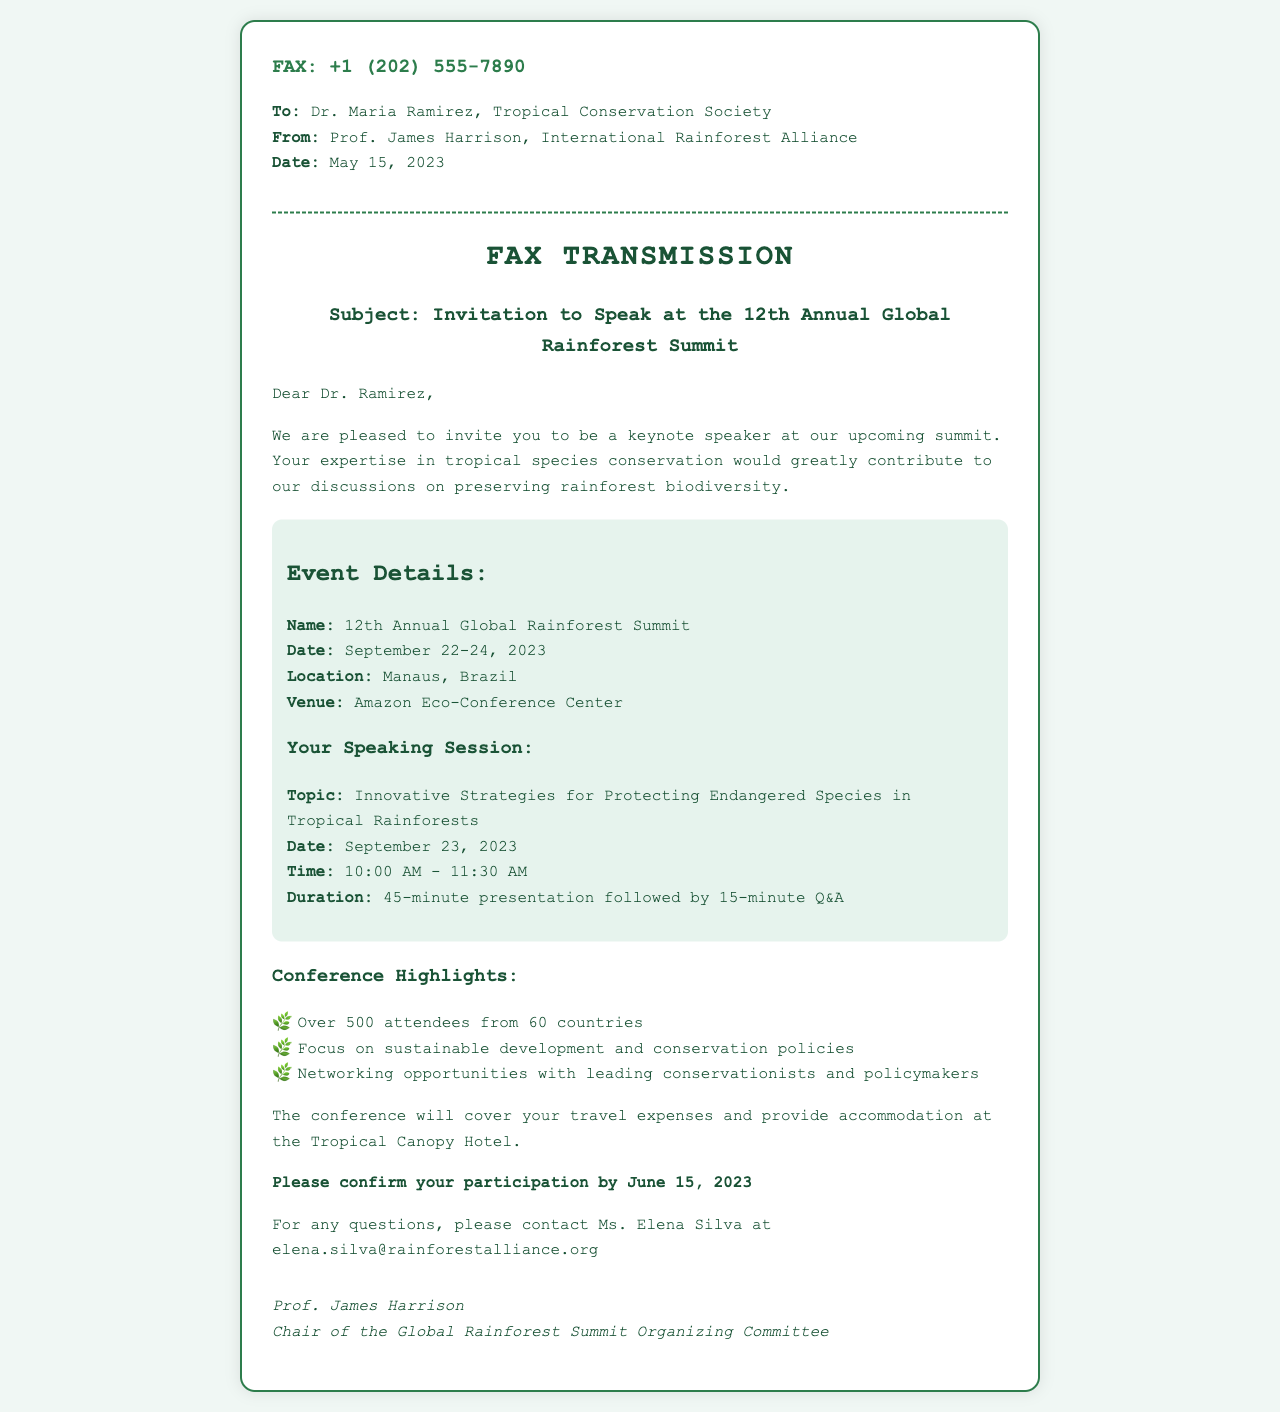What is the fax number? The fax number is provided at the top of the document.
Answer: +1 (202) 555-7890 Who is the recipient of the fax? The document specifies the recipient in the address section.
Answer: Dr. Maria Ramirez When is the conference scheduled to take place? The document states the date of the conference in the event details section.
Answer: September 22-24, 2023 What is the venue of the summit? The venue of the event is mentioned in the event details section.
Answer: Amazon Eco-Conference Center What is the topic of Dr. Ramirez’s speaking session? The topic is outlined in the section describing the speaking session.
Answer: Innovative Strategies for Protecting Endangered Species in Tropical Rainforests How long is the presentation scheduled to last? The duration of the presentation is specified in the event details section.
Answer: 45 minutes What type of expenses will the conference cover? The document mentions which expenses will be covered in relation to the conference.
Answer: Travel expenses What is the confirmation deadline for participation? The deadline for confirmation is indicated in the document.
Answer: June 15, 2023 Who should be contacted for questions regarding the conference? The contact person for questions is mentioned in the latter part of the document.
Answer: Ms. Elena Silva 